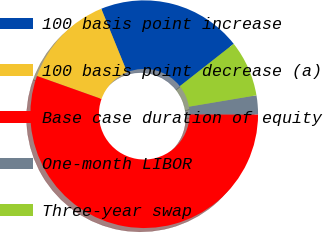Convert chart. <chart><loc_0><loc_0><loc_500><loc_500><pie_chart><fcel>100 basis point increase<fcel>100 basis point decrease (a)<fcel>Base case duration of equity<fcel>One-month LIBOR<fcel>Three-year swap<nl><fcel>20.55%<fcel>13.4%<fcel>55.41%<fcel>2.68%<fcel>7.95%<nl></chart> 